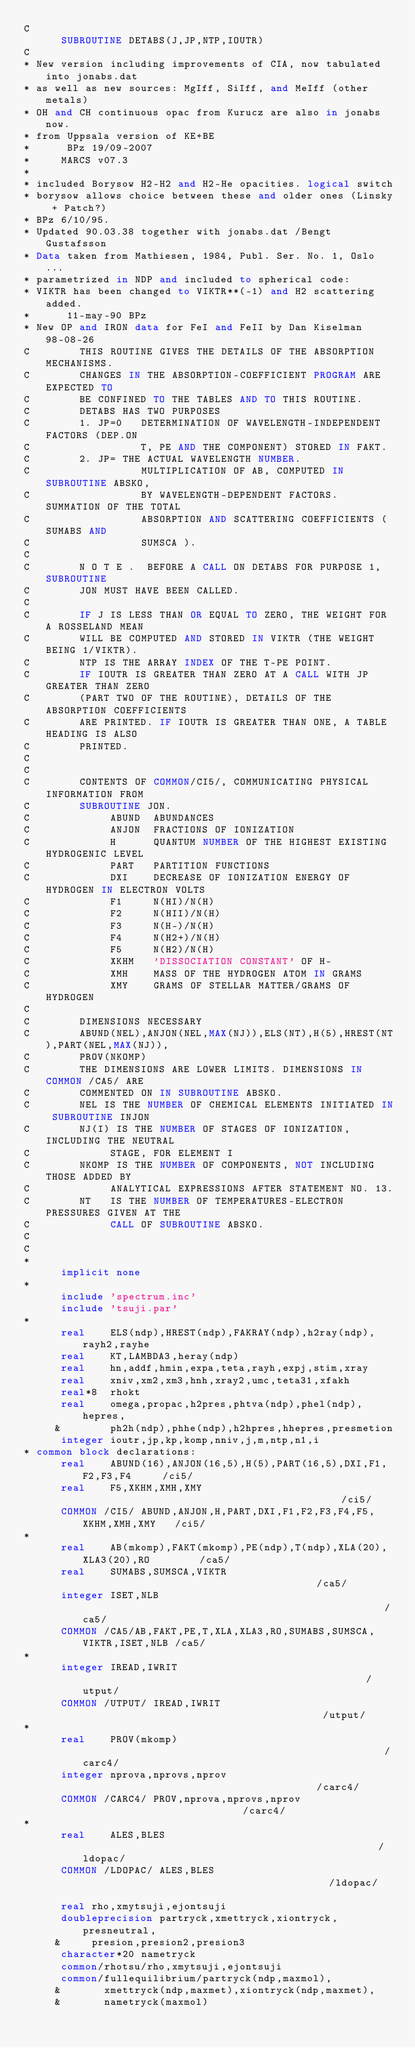<code> <loc_0><loc_0><loc_500><loc_500><_FORTRAN_>C
      SUBROUTINE DETABS(J,JP,NTP,IOUTR)
C
* New version including improvements of CIA, now tabulated into jonabs.dat
* as well as new sources: MgIff, SiIff, and MeIff (other metals)
* OH and CH continuous opac from Kurucz are also in jonabs now.
* from Uppsala version of KE+BE
*      BPz 19/09-2007
*     MARCS v07.3
*
* included Borysow H2-H2 and H2-He opacities. logical switch
* borysow allows choice between these and older ones (Linsky + Patch?)
* BPz 6/10/95.
* Updated 90.03.38 together with jonabs.dat /Bengt Gustafsson
* Data taken from Mathiesen, 1984, Publ. Ser. No. 1, Oslo ...
* parametrized in NDP and included to spherical code:
* VIKTR has been changed to VIKTR**(-1) and H2 scattering added.
*      11-may-90 BPz
* New OP and IRON data for FeI and FeII by Dan Kiselman 98-08-26
C        THIS ROUTINE GIVES THE DETAILS OF THE ABSORPTION MECHANISMS.
C        CHANGES IN THE ABSORPTION-COEFFICIENT PROGRAM ARE EXPECTED TO
C        BE CONFINED TO THE TABLES AND TO THIS ROUTINE.
C        DETABS HAS TWO PURPOSES
C        1. JP=0   DETERMINATION OF WAVELENGTH-INDEPENDENT FACTORS (DEP.ON
C                  T, PE AND THE COMPONENT) STORED IN FAKT.
C        2. JP= THE ACTUAL WAVELENGTH NUMBER.
C                  MULTIPLICATION OF AB, COMPUTED IN SUBROUTINE ABSKO,
C                  BY WAVELENGTH-DEPENDENT FACTORS. SUMMATION OF THE TOTAL
C                  ABSORPTION AND SCATTERING COEFFICIENTS ( SUMABS AND
C                  SUMSCA ).
C
C        N O T E .  BEFORE A CALL ON DETABS FOR PURPOSE 1, SUBROUTINE
C        JON MUST HAVE BEEN CALLED.
C
C        IF J IS LESS THAN OR EQUAL TO ZERO, THE WEIGHT FOR A ROSSELAND MEAN
C        WILL BE COMPUTED AND STORED IN VIKTR (THE WEIGHT BEING 1/VIKTR).
C        NTP IS THE ARRAY INDEX OF THE T-PE POINT.
C        IF IOUTR IS GREATER THAN ZERO AT A CALL WITH JP GREATER THAN ZERO
C        (PART TWO OF THE ROUTINE), DETAILS OF THE ABSORPTION COEFFICIENTS
C        ARE PRINTED. IF IOUTR IS GREATER THAN ONE, A TABLE HEADING IS ALSO
C        PRINTED.
C
C
C        CONTENTS OF COMMON/CI5/, COMMUNICATING PHYSICAL INFORMATION FROM
C        SUBROUTINE JON.
C             ABUND  ABUNDANCES
C             ANJON  FRACTIONS OF IONIZATION
C             H      QUANTUM NUMBER OF THE HIGHEST EXISTING HYDROGENIC LEVEL
C             PART   PARTITION FUNCTIONS
C             DXI    DECREASE OF IONIZATION ENERGY OF HYDROGEN IN ELECTRON VOLTS
C             F1     N(HI)/N(H)
C             F2     N(HII)/N(H)
C             F3     N(H-)/N(H)
C             F4     N(H2+)/N(H)
C             F5     N(H2)/N(H)
C             XKHM   'DISSOCIATION CONSTANT' OF H-
C             XMH    MASS OF THE HYDROGEN ATOM IN GRAMS
C             XMY    GRAMS OF STELLAR MATTER/GRAMS OF HYDROGEN
C
C        DIMENSIONS NECESSARY
C        ABUND(NEL),ANJON(NEL,MAX(NJ)),ELS(NT),H(5),HREST(NT),PART(NEL,MAX(NJ)),
C        PROV(NKOMP)
C        THE DIMENSIONS ARE LOWER LIMITS. DIMENSIONS IN COMMON /CA5/ ARE
C        COMMENTED ON IN SUBROUTINE ABSKO.
C        NEL IS THE NUMBER OF CHEMICAL ELEMENTS INITIATED IN SUBROUTINE INJON
C        NJ(I) IS THE NUMBER OF STAGES OF IONIZATION, INCLUDING THE NEUTRAL
C             STAGE, FOR ELEMENT I
C        NKOMP IS THE NUMBER OF COMPONENTS, NOT INCLUDING THOSE ADDED BY
C             ANALYTICAL EXPRESSIONS AFTER STATEMENT NO. 13.
C        NT   IS THE NUMBER OF TEMPERATURES-ELECTRON PRESSURES GIVEN AT THE
C             CALL OF SUBROUTINE ABSKO.
C
C
*
      implicit none
*
      include 'spectrum.inc'
      include 'tsuji.par'
*
      real    ELS(ndp),HREST(ndp),FAKRAY(ndp),h2ray(ndp),rayh2,rayhe
      real    KT,LAMBDA3,heray(ndp)
      real    hn,addf,hmin,expa,teta,rayh,expj,stim,xray
      real    xniv,xm2,xm3,hnh,xray2,umc,teta31,xfakh
      real*8  rhokt
      real    omega,propac,h2pres,phtva(ndp),phel(ndp),hepres,
     &        ph2h(ndp),phhe(ndp),h2hpres,hhepres,presmetion
      integer ioutr,jp,kp,komp,nniv,j,m,ntp,n1,i
* common block declarations:
      real    ABUND(16),ANJON(16,5),H(5),PART(16,5),DXI,F1,F2,F3,F4     /ci5/
      real    F5,XKHM,XMH,XMY                                           /ci5/
      COMMON /CI5/ ABUND,ANJON,H,PART,DXI,F1,F2,F3,F4,F5,XKHM,XMH,XMY   /ci5/
*
      real    AB(mkomp),FAKT(mkomp),PE(ndp),T(ndp),XLA(20),XLA3(20),RO        /ca5/
      real    SUMABS,SUMSCA,VIKTR                                       /ca5/
      integer ISET,NLB                                                  /ca5/
      COMMON /CA5/AB,FAKT,PE,T,XLA,XLA3,RO,SUMABS,SUMSCA,VIKTR,ISET,NLB /ca5/
*
      integer IREAD,IWRIT                                               /utput/
      COMMON /UTPUT/ IREAD,IWRIT                                        /utput/
*
      real    PROV(mkomp)                                                  /carc4/
      integer nprova,nprovs,nprov                                       /carc4/
      COMMON /CARC4/ PROV,nprova,nprovs,nprov                           /carc4/
*
      real    ALES,BLES                                                 /ldopac/
      COMMON /LDOPAC/ ALES,BLES                                         /ldopac/

      real rho,xmytsuji,ejontsuji
      doubleprecision partryck,xmettryck,xiontryck,presneutral,
     &     presion,presion2,presion3
      character*20 nametryck
      common/rhotsu/rho,xmytsuji,ejontsuji
      common/fullequilibrium/partryck(ndp,maxmol),
     &       xmettryck(ndp,maxmet),xiontryck(ndp,maxmet),
     &       nametryck(maxmol)</code> 